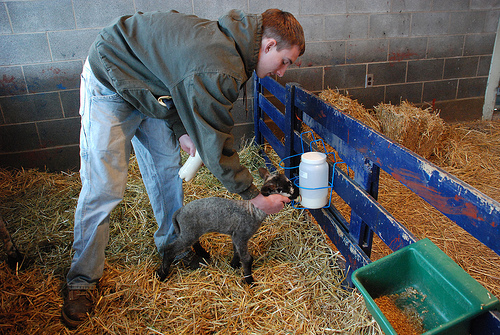<image>
Is there a man to the left of the sheep? Yes. From this viewpoint, the man is positioned to the left side relative to the sheep. 